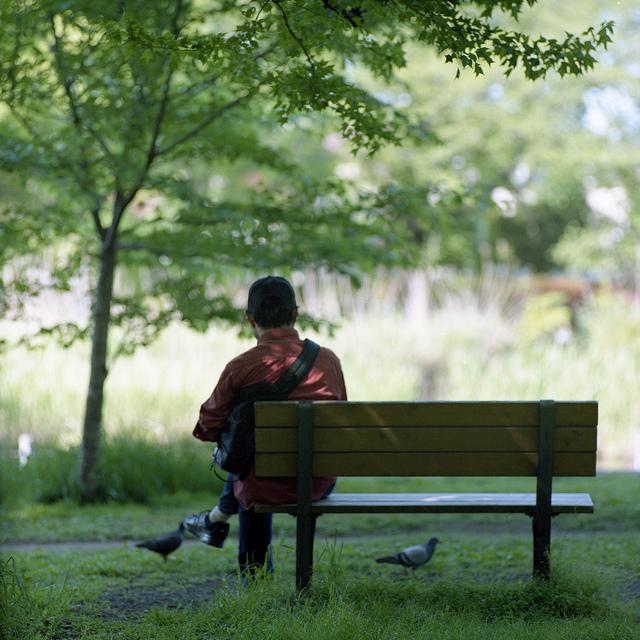How many birds are there?
Keep it brief. 2. Was the bench just painted?
Concise answer only. No. What color is the photo?
Answer briefly. Green. What is the back of the bench made of?
Quick response, please. Wood. What color hat is the person on the left wearing?
Short answer required. Black. Is this a tourist event?
Short answer required. No. What is the center of the picture?
Be succinct. Bench. Is the bench sitting on grass?
Be succinct. Yes. Is the ground sandy or grassy?
Short answer required. Grassy. What does the man have on his back?
Answer briefly. Backpack. Is the person on the bench stressed or tired?
Quick response, please. Tired. How many chairs are there?
Keep it brief. 1. What is on the ground next to the bench?
Answer briefly. Bird. How many people are pictured?
Be succinct. 1. How many benches are pictured?
Be succinct. 1. Does the grass need to be mowed?
Quick response, please. Yes. What color is the bag?
Write a very short answer. Black. What is wrong with the bench?
Be succinct. Nothing. What are the picture looking at?
Short answer required. Nature. Is he sitting in the sun?
Short answer required. No. Is she anxiously awaiting something?
Write a very short answer. No. Does the grass need to be cut?
Keep it brief. Yes. What is on the ground next to the chair?
Keep it brief. Pigeons. What is the bench made out of?
Quick response, please. Wood. What is underneath the bench?
Short answer required. Bird. What color is the man's shirt?
Quick response, please. Red. What is the man sitting on?
Be succinct. Bench. Why are the people sitting there?
Be succinct. Resting. Is there graffiti on the bench?
Short answer required. No. Can you see any birds?
Give a very brief answer. Yes. Is there water in the picture?
Give a very brief answer. No. What is worn on their heads?
Write a very short answer. Hat. 